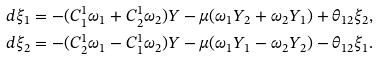<formula> <loc_0><loc_0><loc_500><loc_500>d \xi _ { 1 } & = - ( C _ { 1 } ^ { 1 } \omega _ { 1 } + C _ { 2 } ^ { 1 } \omega _ { 2 } ) Y - \mu ( \omega _ { 1 } Y _ { 2 } + \omega _ { 2 } Y _ { 1 } ) + \theta _ { 1 2 } \xi _ { 2 } , \\ d \xi _ { 2 } & = - ( C _ { 2 } ^ { 1 } \omega _ { 1 } - C _ { 1 } ^ { 1 } \omega _ { 2 } ) Y - \mu ( \omega _ { 1 } Y _ { 1 } - \omega _ { 2 } Y _ { 2 } ) - \theta _ { 1 2 } \xi _ { 1 } .</formula> 